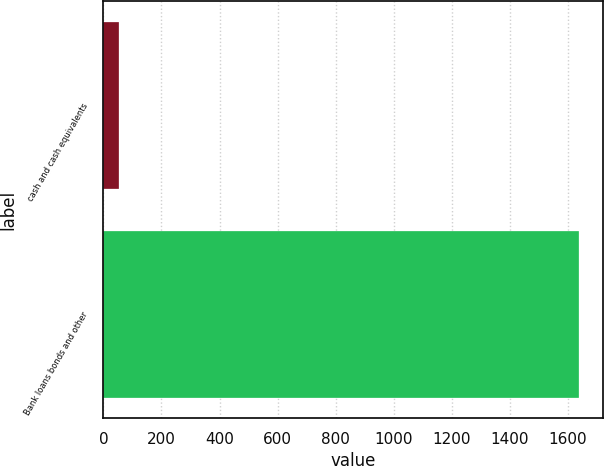Convert chart. <chart><loc_0><loc_0><loc_500><loc_500><bar_chart><fcel>cash and cash equivalents<fcel>Bank loans bonds and other<nl><fcel>54<fcel>1639<nl></chart> 